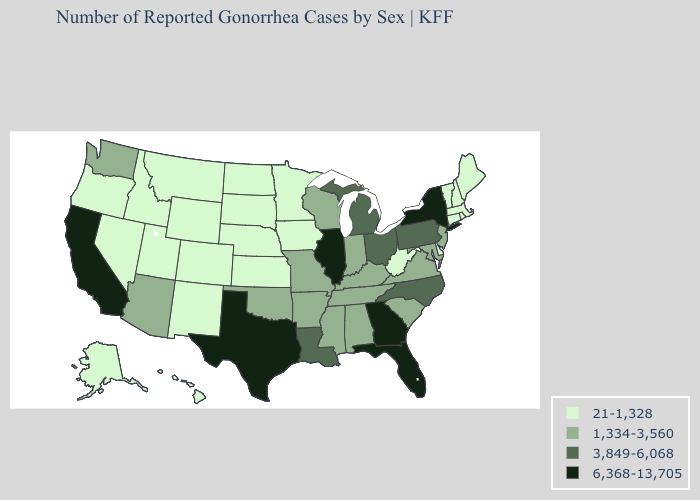Name the states that have a value in the range 3,849-6,068?
Concise answer only. Louisiana, Michigan, North Carolina, Ohio, Pennsylvania. What is the value of Alaska?
Give a very brief answer. 21-1,328. What is the lowest value in the West?
Keep it brief. 21-1,328. Does Missouri have a lower value than Georgia?
Be succinct. Yes. Which states have the highest value in the USA?
Quick response, please. California, Florida, Georgia, Illinois, New York, Texas. Does Colorado have a lower value than Illinois?
Be succinct. Yes. What is the value of West Virginia?
Keep it brief. 21-1,328. What is the value of Iowa?
Be succinct. 21-1,328. Name the states that have a value in the range 21-1,328?
Write a very short answer. Alaska, Colorado, Connecticut, Delaware, Hawaii, Idaho, Iowa, Kansas, Maine, Massachusetts, Minnesota, Montana, Nebraska, Nevada, New Hampshire, New Mexico, North Dakota, Oregon, Rhode Island, South Dakota, Utah, Vermont, West Virginia, Wyoming. Among the states that border Nebraska , does South Dakota have the highest value?
Keep it brief. No. What is the lowest value in the USA?
Keep it brief. 21-1,328. Does Ohio have a higher value than New Jersey?
Write a very short answer. Yes. What is the value of Rhode Island?
Answer briefly. 21-1,328. Among the states that border New Mexico , which have the lowest value?
Quick response, please. Colorado, Utah. 